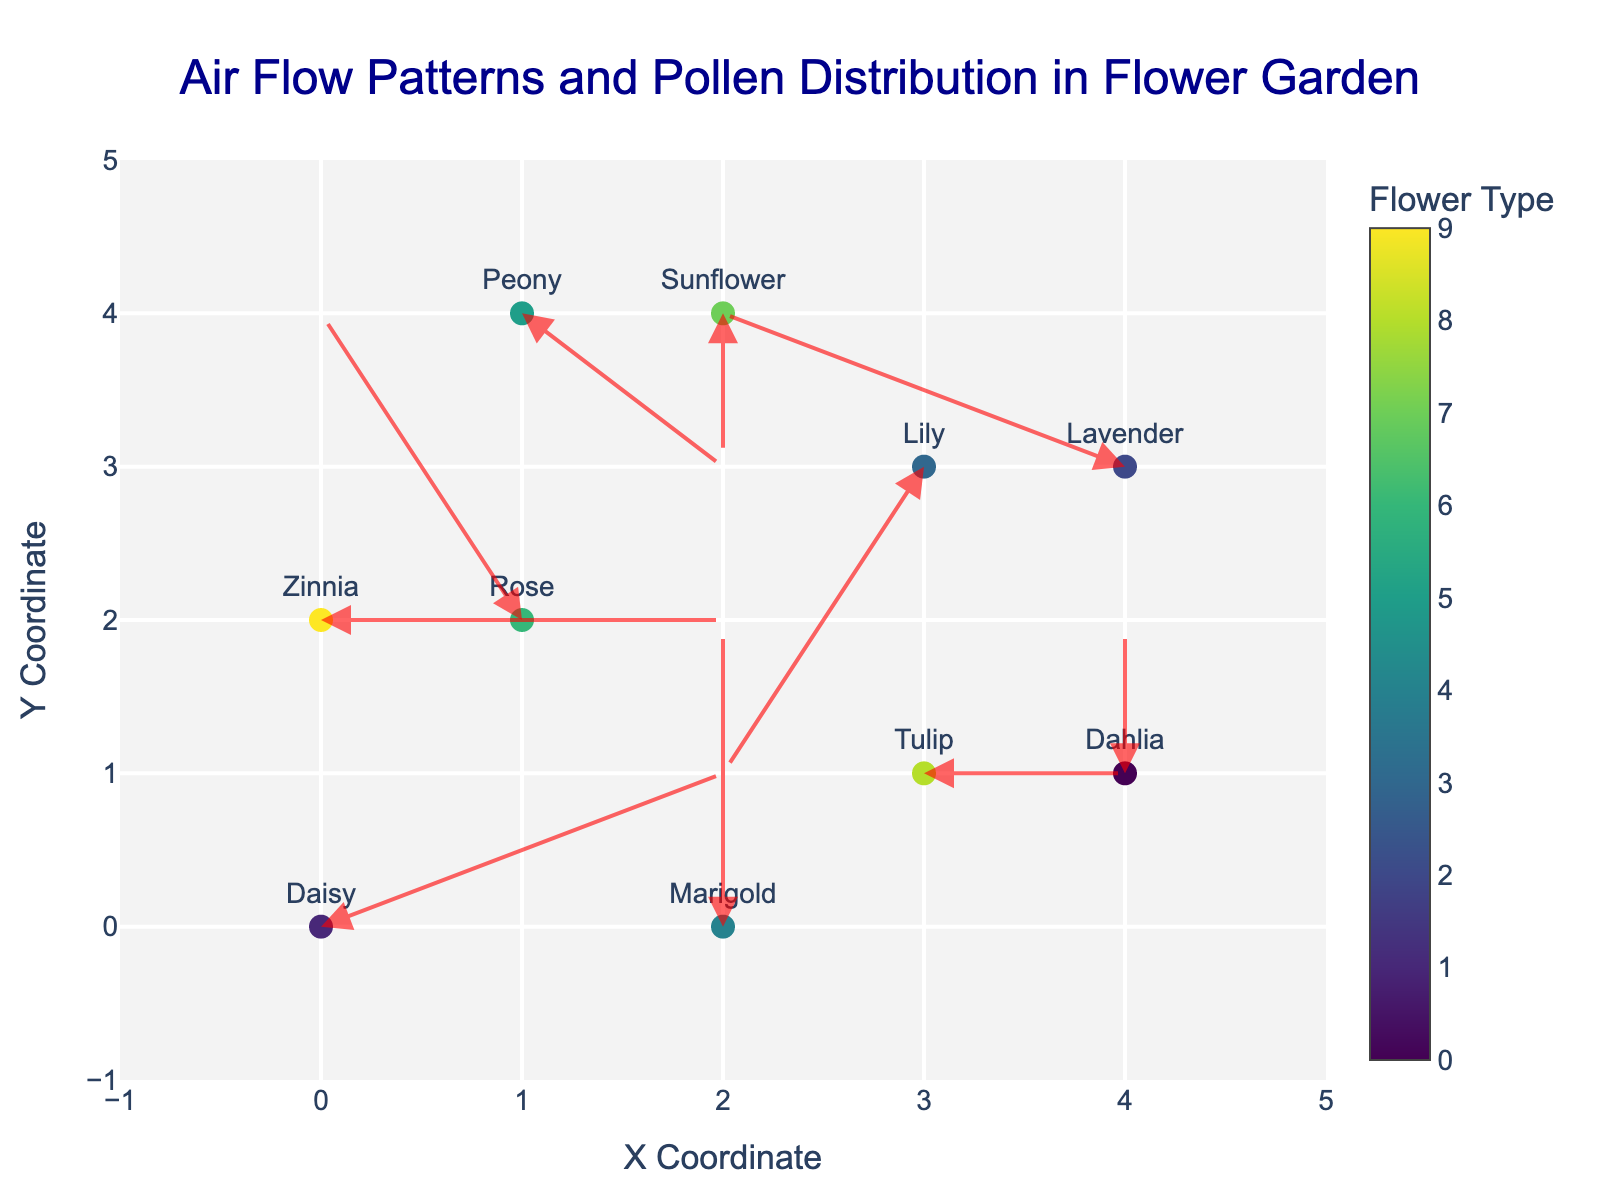How many flower types are represented in the plot? By observing the figure, count the distinct colors or unique flower names indicated by the marker labels, as each flower type has a unique color or name.
Answer: 10 What are the x and y coordinates of the 'Rose' flower? Locate the 'Rose' text label on the plot and read off the corresponding x and y-axis coordinates.
Answer: (1, 2) Which flower type is influenced by an air flow vector pointing directly downwards? Identify the arrow that points directly downwards (v is negative, u is zero). Observe the flower type label at the base of this arrow.
Answer: Sunflower What is the net horizontal displacement for all the flower types with positive u components? Identify the 'Daisy,' 'Tulip,' 'Zinnia,' and 'Peony' (positive u values), sum their u values: 2 + 1 + 2 + 1 = 6.
Answer: 6 Which flower experiences the longest air flow vector? Calculate the length of each vector using the formula √(u² + v²), and identify the one with the greatest value. In this case, 'Rose' with vector (-1,2): √((-1)² + 2²) = √(1 + 4) = √5 ≈ 2.24.
Answer: Rose What is the average x coordinate of all flower types? Sum all the x coordinates and divide by the number of flower types: (0 + 1 + 2 + 3 + 4 + 2 + 1 + 3 + 0 + 4) / 10 = 20 / 10 = 2.
Answer: 2 Which flower type has an air flow vector directed towards the top left? Look for vectors with both a negative u and a positive v component. Identify the flower type with these vector components.
Answer: None 